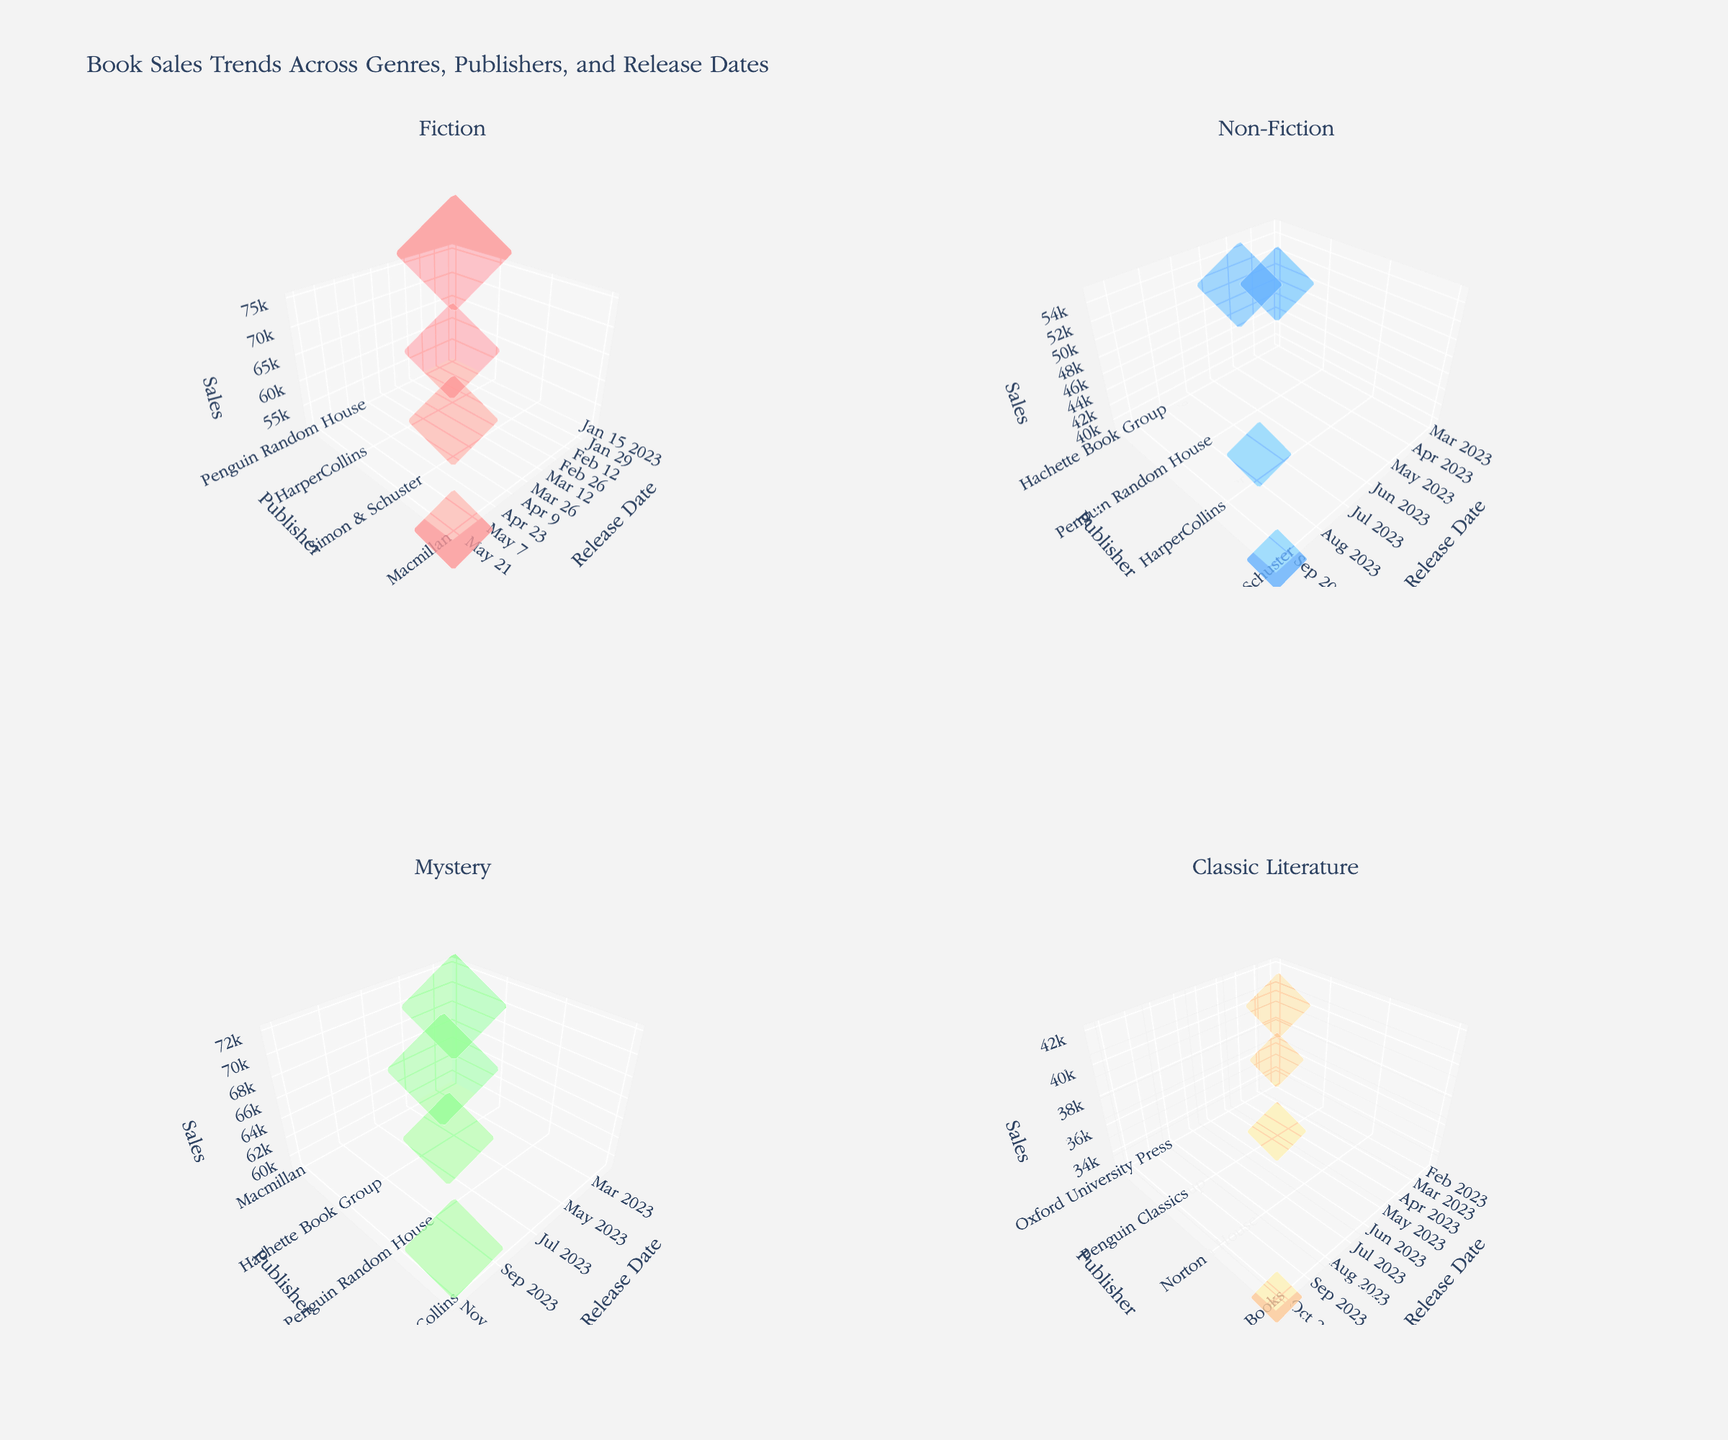How many subplots are there in the figure? The figure contains four subplots, each representing different genres (Fiction, Non-Fiction, Mystery, Classic Literature). This can be seen from the titles and their arrangement in a 2x2 grid.
Answer: Four What is the main title of the figure? The main title of the figure is prominently displayed at the top and reads "Book Sales Trends Across Genres, Publishers, and Release Dates".
Answer: Book Sales Trends Across Genres, Publishers, and Release Dates Which publisher has the highest sales in the 'Mystery' genre? In the 'Mystery' genre subplot, the data point with the highest sales is the one associated with Penguin Random House, reaching 72,000 sales.
Answer: Penguin Random House For which genre did 'HarperCollins' release a book in November? By examining the release dates in the subplots, it is evident that HarperCollins released a book in November in the 'Mystery' genre, specifically on November 5th.
Answer: Mystery What is the average sales figure for books released in the 'Poetry' genre? In the 'Poetry' genre, the sales figures are 18,000, 15,000, 20,000, and 16,000. Summing these gives 69,000, and the average is 69,000 divided by 4, which equals 17,250.
Answer: 17,250 Compare the sales of Fiction books released in January and April. Which one has higher sales? For Fiction, the January release from Penguin Random House has 75,000 sales, and the April release from Simon & Schuster has 58,000 sales. Hence, the January release has higher sales.
Answer: January Which genre has the lowest average sales figure? To find this, calculate the average sales of each genre: 
  
  - Fiction: (75,000 + 62,000 + 58,000 + 51,000)/4 = 61,500
  - Non-Fiction: (48,000 + 55,000 + 42,000 + 39,000)/4 = 46,000
  - Mystery: (68,000 + 59,000 + 72,000 + 64,000)/4 = 65,750
  - Classic Literature: (35,000 + 42,000 + 38,000 + 33,000)/4 = 37,000
  - Poetry: (18,000 + 15,000 + 20,000 + 16,000)/4 = 17,250
  
  The lowest average is for Poetry with 17,250.
Answer: Poetry How many unique publishers released books in the 'Classic Literature' genre? By counting the unique publishers in the 'Classic Literature' genre subplot, we have Oxford University Press, Penguin Classics, Norton, and Vintage Books, making a total of 4 unique publishers.
Answer: Four Which genre experienced the highest sales in a single release, and what was the sales figure? Observing all subplots, the highest sales in a single release occur in the 'Fiction' genre by Penguin Random House with 75,000 sales.
Answer: Fiction, 75,000 